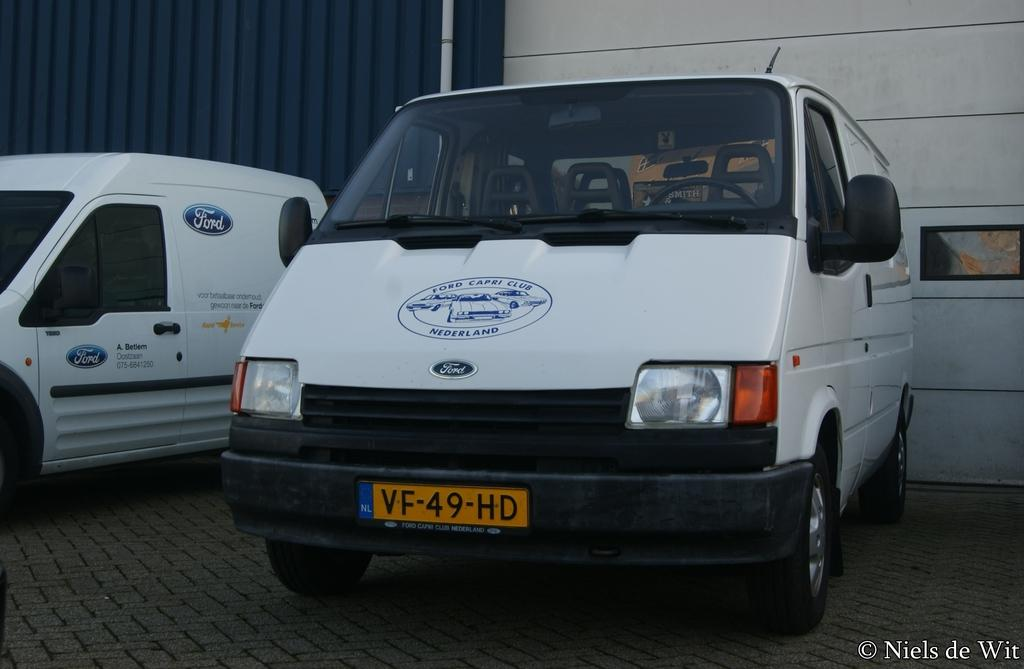<image>
Create a compact narrative representing the image presented. the license plate that reads VF on it 